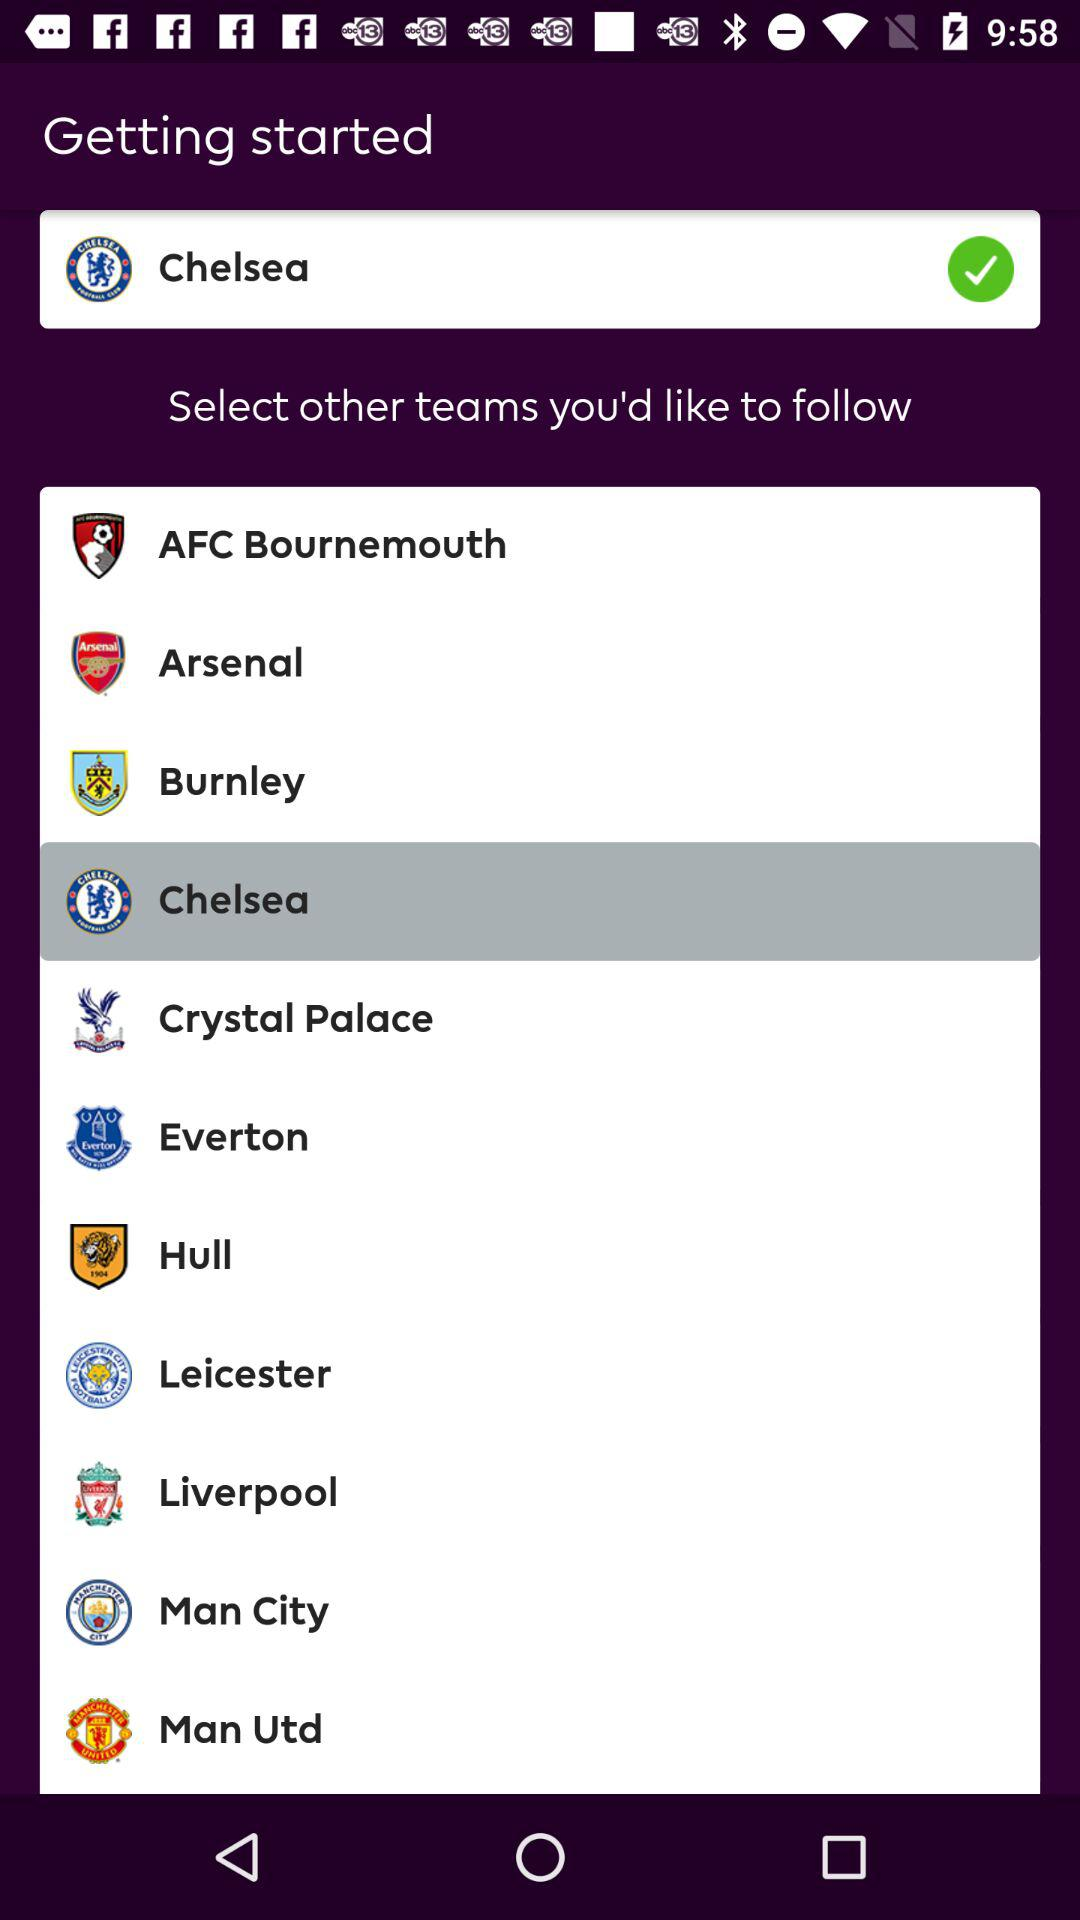Which is the selected team? The selected team is "Chelsea". 